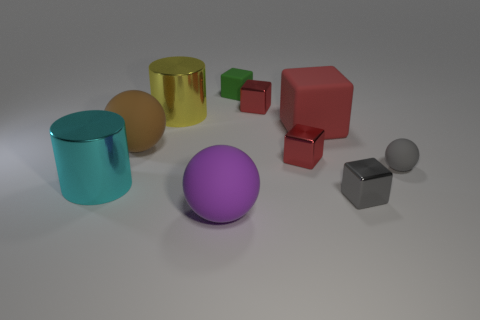There is a large rubber ball that is behind the purple matte ball; what is its color?
Offer a very short reply. Brown. There is a tiny block that is the same color as the small matte sphere; what material is it?
Your answer should be compact. Metal. Are there any cubes in front of the green matte thing?
Ensure brevity in your answer.  Yes. Is the number of tiny rubber spheres greater than the number of big gray cylinders?
Your response must be concise. Yes. What color is the shiny cube that is in front of the metal cylinder left of the big sphere on the left side of the large purple sphere?
Provide a succinct answer. Gray. The big block that is the same material as the brown ball is what color?
Keep it short and to the point. Red. Are there any other things that have the same size as the brown thing?
Your answer should be compact. Yes. What number of objects are either large rubber objects to the left of the large purple object or rubber objects in front of the small green cube?
Offer a terse response. 4. There is a metallic cube that is in front of the large cyan object; is it the same size as the rubber sphere that is behind the gray matte object?
Offer a terse response. No. There is a large rubber object that is the same shape as the small green object; what color is it?
Give a very brief answer. Red. 